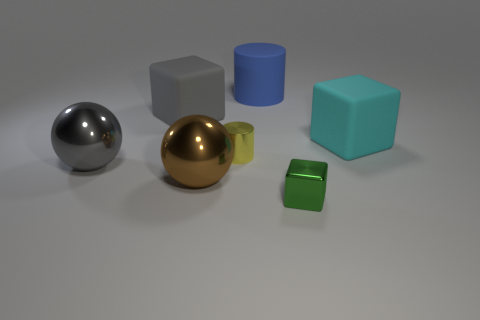Which of the objects in the image appears to be in front of all the others? The small green cube appears to be in the foreground, positioned in front of all the other objects. Its size, placement, and the sharpness of its edges in relation to the rest of the objects help to create this visual hierarchy within the image. 